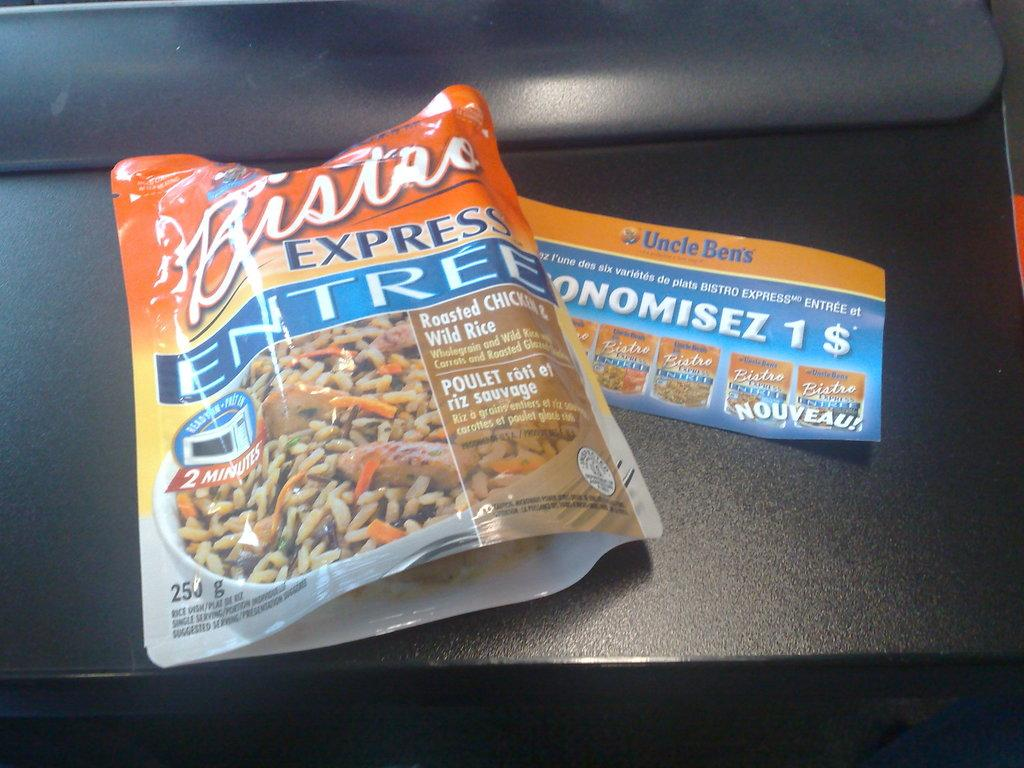What is present in the image that is enclosed or wrapped? There is a packet in the image. What type of writing material is visible in the image? There is a paper in the image. What is the color of the surface in the image? The surface in the image is black. What type of protest is taking place in the image? There is no protest present in the image. How many spades can be seen in the image? There are no spades present in the image. 